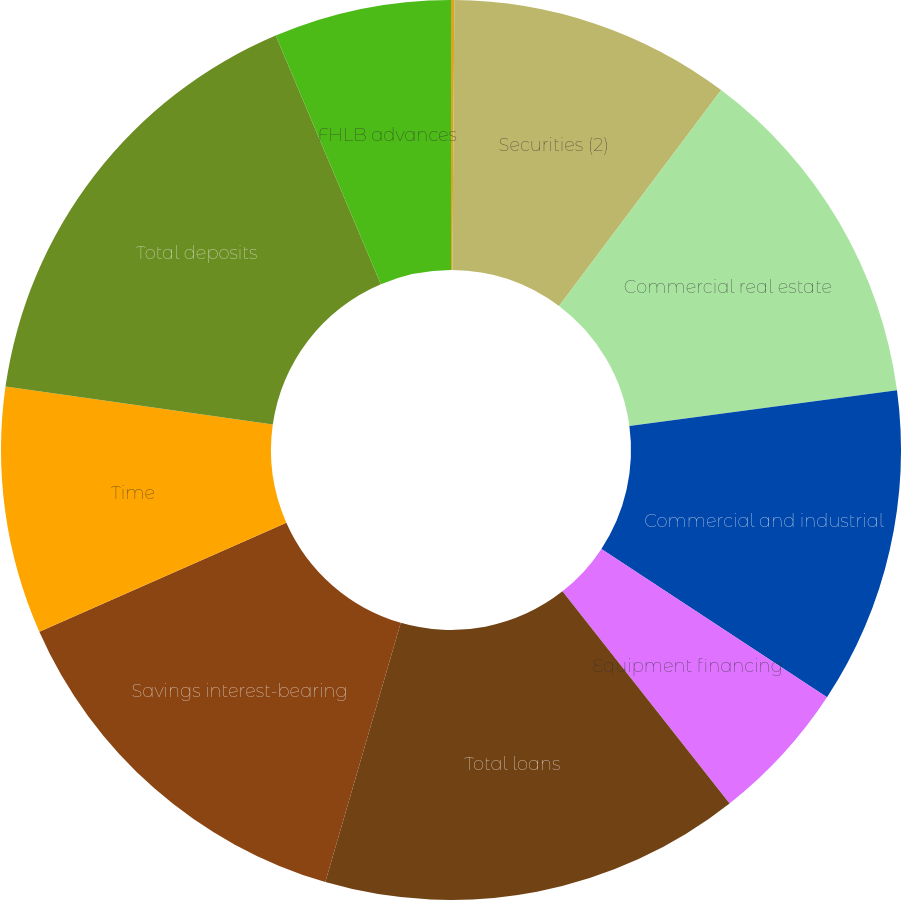Convert chart to OTSL. <chart><loc_0><loc_0><loc_500><loc_500><pie_chart><fcel>Short-term investments (1)<fcel>Securities (2)<fcel>Commercial real estate<fcel>Commercial and industrial<fcel>Equipment financing<fcel>Total loans<fcel>Savings interest-bearing<fcel>Time<fcel>Total deposits<fcel>FHLB advances<nl><fcel>0.12%<fcel>10.13%<fcel>12.63%<fcel>11.38%<fcel>5.12%<fcel>15.13%<fcel>13.88%<fcel>8.87%<fcel>16.38%<fcel>6.37%<nl></chart> 